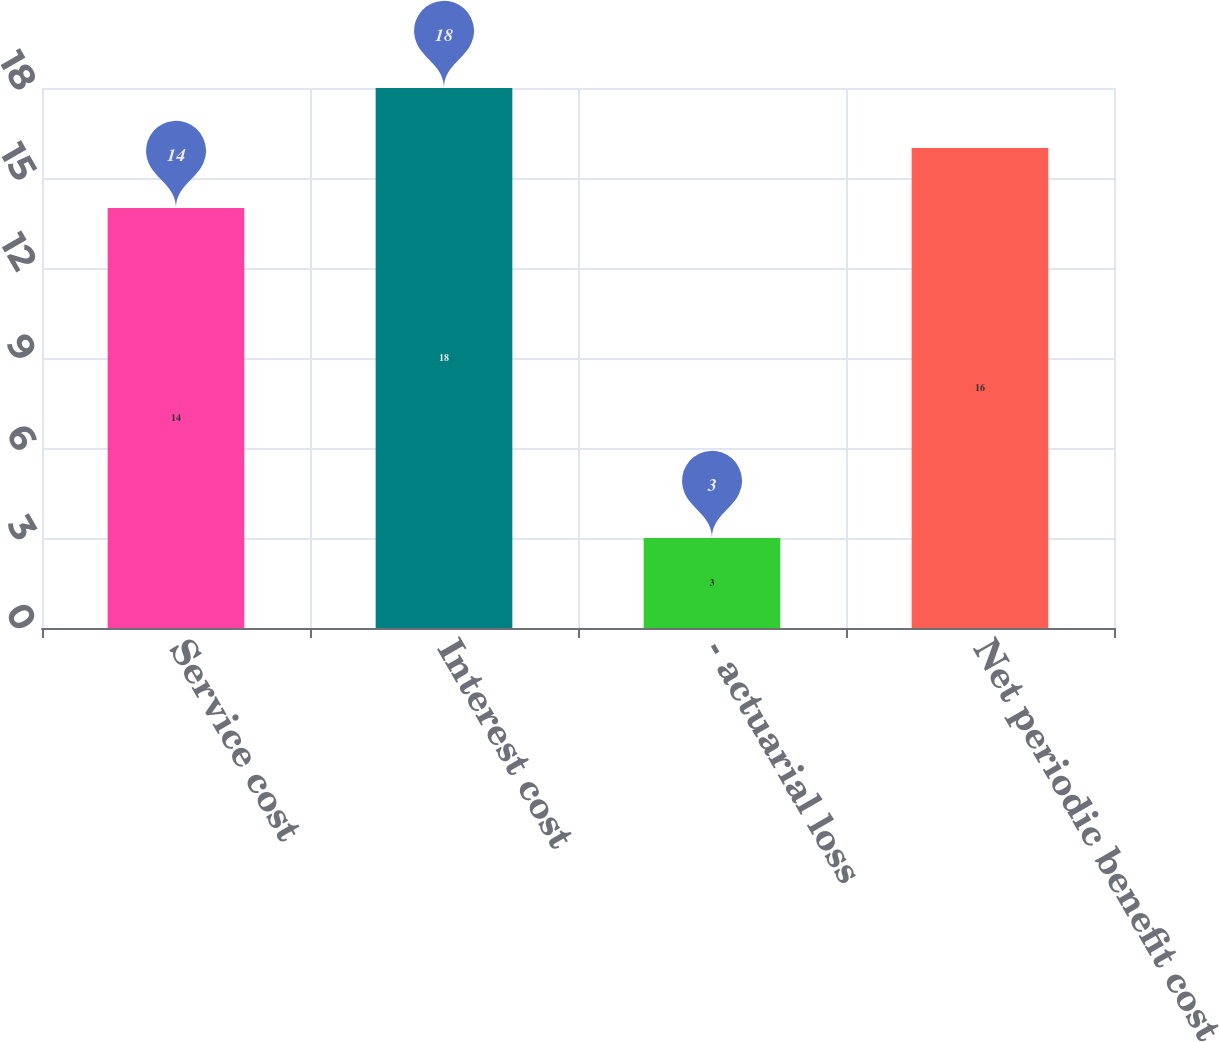<chart> <loc_0><loc_0><loc_500><loc_500><bar_chart><fcel>Service cost<fcel>Interest cost<fcel>- actuarial loss<fcel>Net periodic benefit cost<nl><fcel>14<fcel>18<fcel>3<fcel>16<nl></chart> 